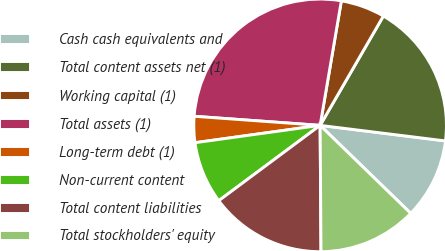Convert chart to OTSL. <chart><loc_0><loc_0><loc_500><loc_500><pie_chart><fcel>Cash cash equivalents and<fcel>Total content assets net (1)<fcel>Working capital (1)<fcel>Total assets (1)<fcel>Long-term debt (1)<fcel>Non-current content<fcel>Total content liabilities<fcel>Total stockholders' equity<nl><fcel>10.3%<fcel>18.62%<fcel>5.66%<fcel>26.54%<fcel>3.34%<fcel>7.98%<fcel>14.94%<fcel>12.62%<nl></chart> 